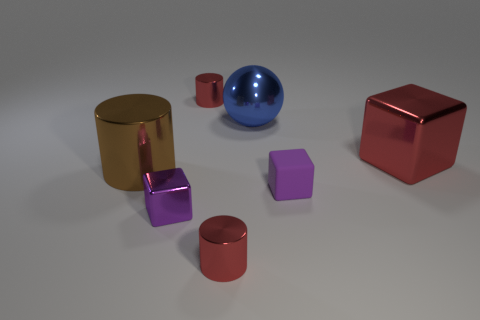Do the small metal cube and the matte cube have the same color?
Provide a succinct answer. Yes. Are the red thing that is in front of the large red object and the large blue ball made of the same material?
Your answer should be compact. Yes. What is the material of the small purple thing to the left of the small red object to the left of the red cylinder that is in front of the small purple rubber cube?
Provide a succinct answer. Metal. How many other objects are the same shape as the purple shiny thing?
Offer a terse response. 2. What color is the tiny cylinder in front of the blue sphere?
Keep it short and to the point. Red. There is a large thing that is to the left of the red object behind the shiny sphere; what number of large red shiny blocks are in front of it?
Your answer should be very brief. 0. What number of blocks are in front of the block that is behind the big metal cylinder?
Keep it short and to the point. 2. How many purple metallic objects are left of the red cube?
Give a very brief answer. 1. How many other objects are the same size as the purple rubber cube?
Offer a very short reply. 3. There is a red shiny object that is the same shape as the tiny purple rubber thing; what is its size?
Your answer should be compact. Large. 